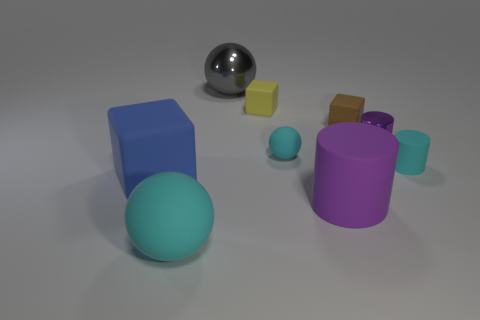Subtract all blue blocks. How many blocks are left? 2 Subtract all gray balls. How many balls are left? 2 Subtract all yellow balls. How many purple cylinders are left? 2 Subtract 1 cylinders. How many cylinders are left? 2 Subtract all red cylinders. Subtract all brown blocks. How many cylinders are left? 3 Subtract 0 cyan blocks. How many objects are left? 9 Subtract all spheres. How many objects are left? 6 Subtract all small matte things. Subtract all large green rubber things. How many objects are left? 5 Add 2 small brown matte blocks. How many small brown matte blocks are left? 3 Add 6 big cyan objects. How many big cyan objects exist? 7 